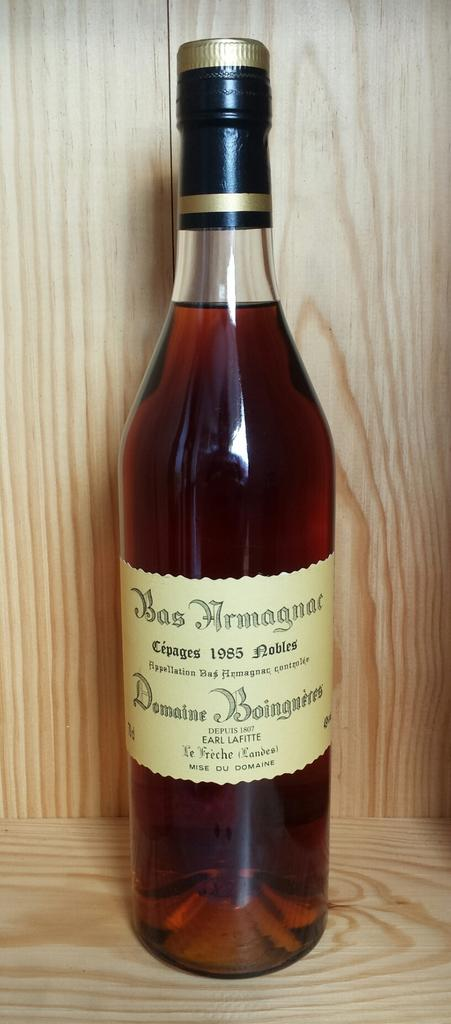<image>
Share a concise interpretation of the image provided. A large bottle of Bas Armagnac made in 1985 